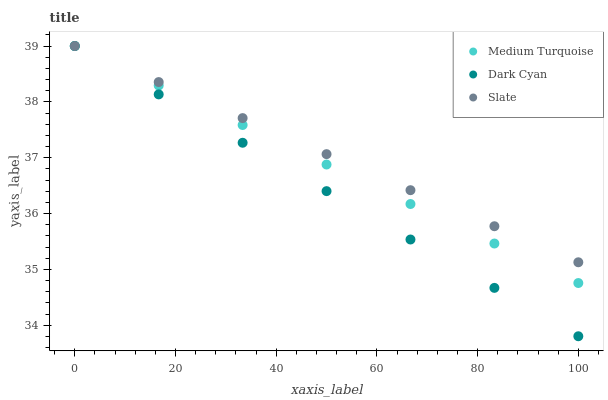Does Dark Cyan have the minimum area under the curve?
Answer yes or no. Yes. Does Slate have the maximum area under the curve?
Answer yes or no. Yes. Does Medium Turquoise have the minimum area under the curve?
Answer yes or no. No. Does Medium Turquoise have the maximum area under the curve?
Answer yes or no. No. Is Slate the smoothest?
Answer yes or no. Yes. Is Medium Turquoise the roughest?
Answer yes or no. Yes. Is Medium Turquoise the smoothest?
Answer yes or no. No. Is Slate the roughest?
Answer yes or no. No. Does Dark Cyan have the lowest value?
Answer yes or no. Yes. Does Medium Turquoise have the lowest value?
Answer yes or no. No. Does Medium Turquoise have the highest value?
Answer yes or no. Yes. Does Slate intersect Dark Cyan?
Answer yes or no. Yes. Is Slate less than Dark Cyan?
Answer yes or no. No. Is Slate greater than Dark Cyan?
Answer yes or no. No. 